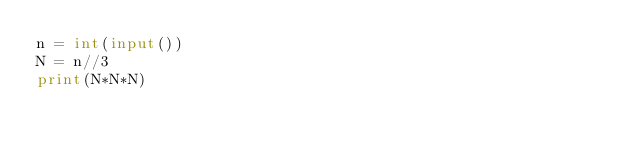Convert code to text. <code><loc_0><loc_0><loc_500><loc_500><_Python_>n = int(input())
N = n//3
print(N*N*N)
</code> 